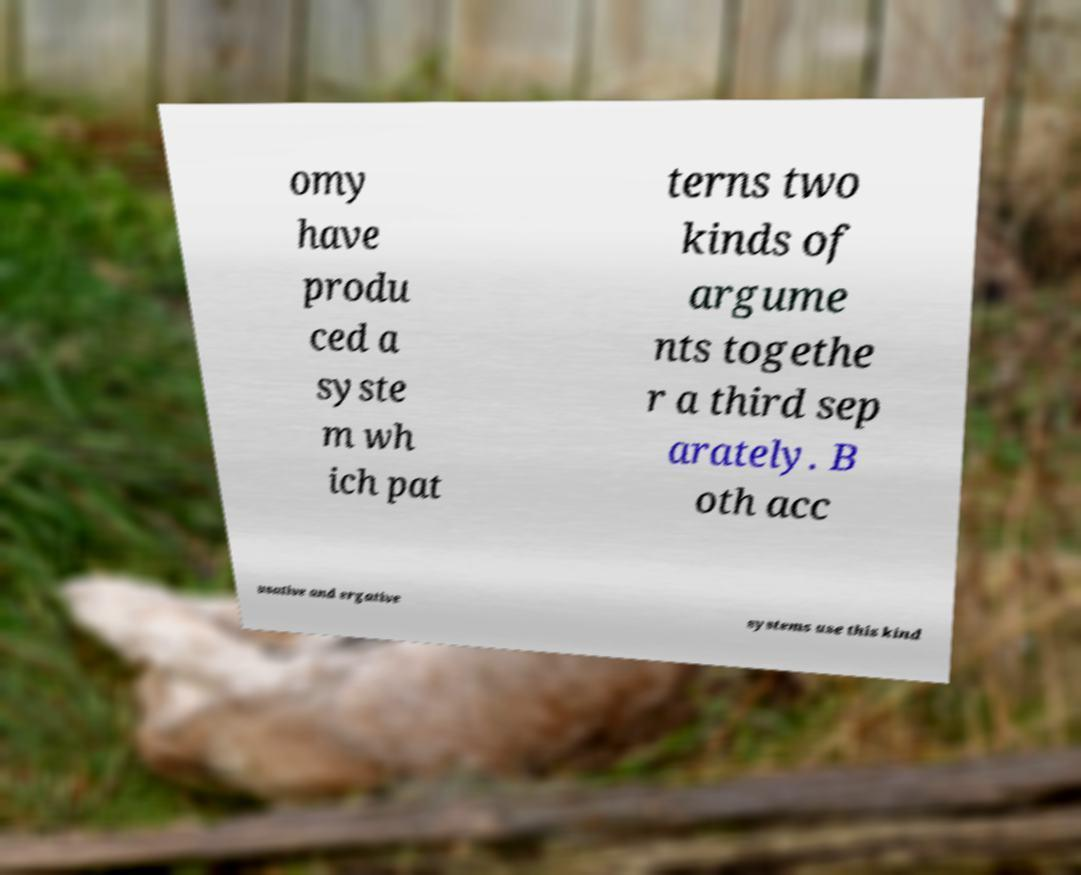Can you read and provide the text displayed in the image?This photo seems to have some interesting text. Can you extract and type it out for me? omy have produ ced a syste m wh ich pat terns two kinds of argume nts togethe r a third sep arately. B oth acc usative and ergative systems use this kind 